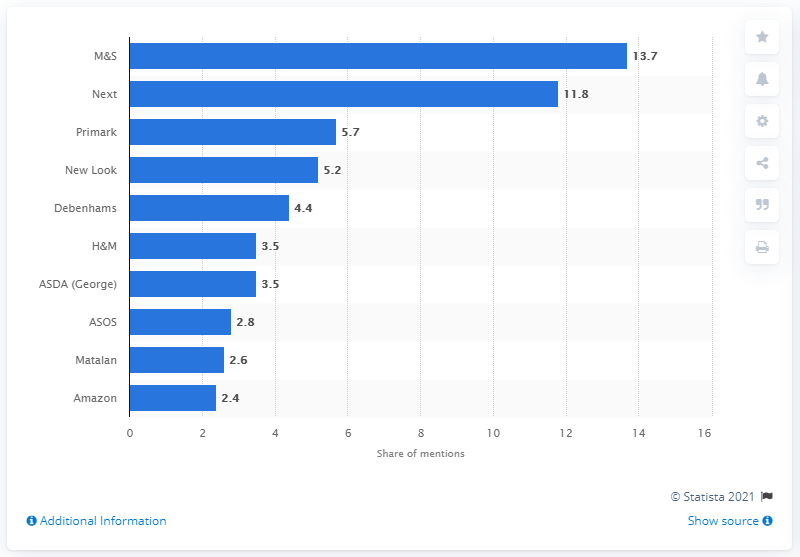Outline some significant characteristics in this image. Amazon was the most popular online store in the UK in 2016. In the survey, Primark was mentioned as having a share of 5.7%. According to the survey, Next's share of mentions was 11.8.. In 2016, Marks & Spencer was the most popular clothing retailer in the United Kingdom, as reported by industry sources. 